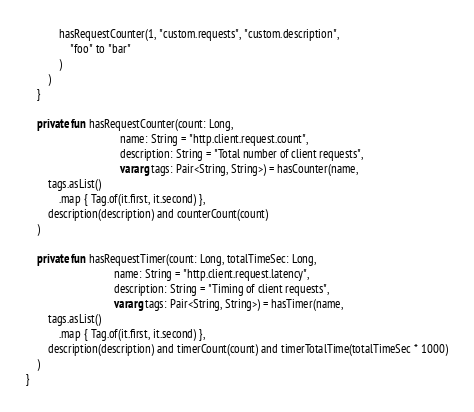<code> <loc_0><loc_0><loc_500><loc_500><_Kotlin_>            hasRequestCounter(1, "custom.requests", "custom.description",
                "foo" to "bar"
            )
        )
    }

    private fun hasRequestCounter(count: Long,
                                  name: String = "http.client.request.count",
                                  description: String = "Total number of client requests",
                                  vararg tags: Pair<String, String>) = hasCounter(name,
        tags.asList()
            .map { Tag.of(it.first, it.second) },
        description(description) and counterCount(count)
    )

    private fun hasRequestTimer(count: Long, totalTimeSec: Long,
                                name: String = "http.client.request.latency",
                                description: String = "Timing of client requests",
                                vararg tags: Pair<String, String>) = hasTimer(name,
        tags.asList()
            .map { Tag.of(it.first, it.second) },
        description(description) and timerCount(count) and timerTotalTime(totalTimeSec * 1000)
    )
}
</code> 